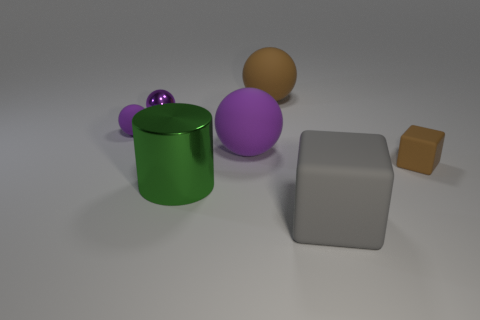There is a tiny thing that is the same color as the metal ball; what material is it?
Provide a succinct answer. Rubber. What shape is the purple thing in front of the rubber object that is left of the metallic cylinder?
Your answer should be very brief. Sphere. What number of gray matte blocks are behind the brown rubber object behind the tiny object in front of the large purple thing?
Provide a short and direct response. 0. Is the number of small matte things that are on the right side of the big purple sphere less than the number of large purple matte objects?
Give a very brief answer. No. Is there anything else that is the same shape as the large metallic thing?
Give a very brief answer. No. There is a brown rubber object in front of the tiny metallic object; what is its shape?
Provide a short and direct response. Cube. What is the shape of the tiny matte object that is right of the large shiny cylinder that is in front of the small ball in front of the tiny purple metallic sphere?
Keep it short and to the point. Cube. How many objects are either small brown metal cubes or balls?
Provide a short and direct response. 4. Do the large object that is on the left side of the big purple thing and the tiny matte object that is left of the small brown thing have the same shape?
Offer a very short reply. No. How many rubber objects are both on the right side of the large brown matte object and on the left side of the shiny cylinder?
Make the answer very short. 0. 